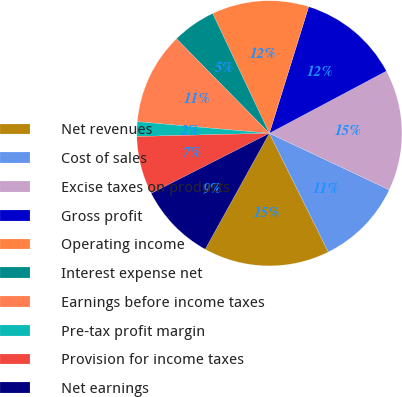<chart> <loc_0><loc_0><loc_500><loc_500><pie_chart><fcel>Net revenues<fcel>Cost of sales<fcel>Excise taxes on products<fcel>Gross profit<fcel>Operating income<fcel>Interest expense net<fcel>Earnings before income taxes<fcel>Pre-tax profit margin<fcel>Provision for income taxes<fcel>Net earnings<nl><fcel>15.38%<fcel>10.65%<fcel>14.79%<fcel>12.43%<fcel>11.83%<fcel>5.33%<fcel>11.24%<fcel>1.78%<fcel>7.1%<fcel>9.47%<nl></chart> 